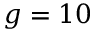Convert formula to latex. <formula><loc_0><loc_0><loc_500><loc_500>g = 1 0</formula> 